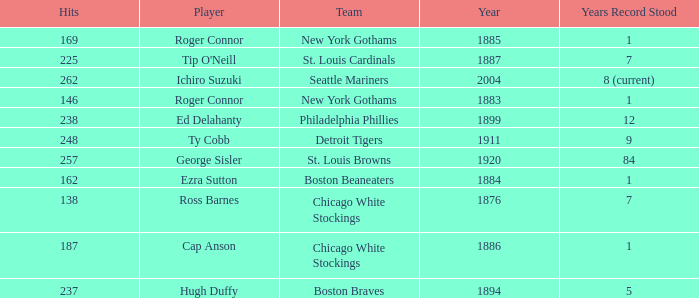Name the player with 238 hits and years after 1885 Ed Delahanty. 